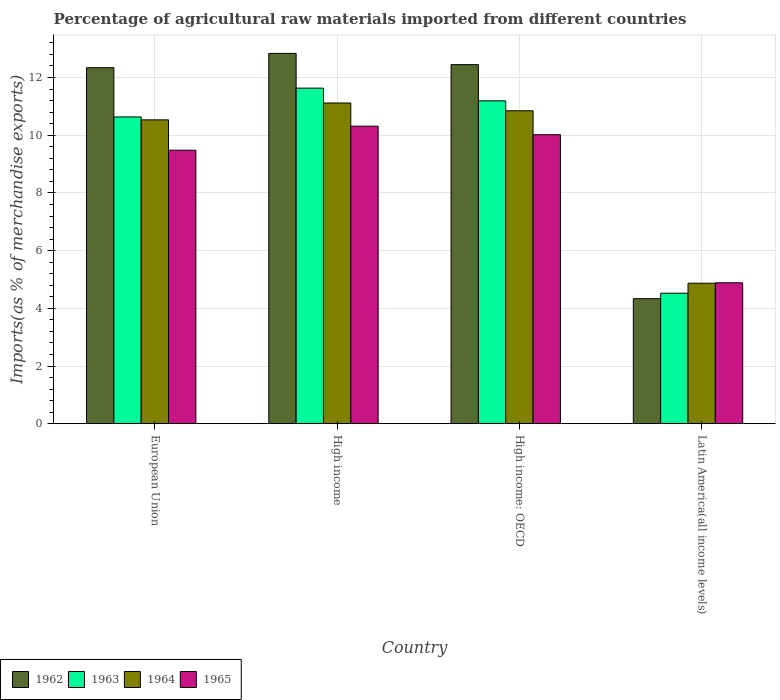How many different coloured bars are there?
Offer a very short reply. 4. Are the number of bars on each tick of the X-axis equal?
Provide a succinct answer. Yes. How many bars are there on the 4th tick from the right?
Provide a short and direct response. 4. What is the label of the 3rd group of bars from the left?
Your response must be concise. High income: OECD. In how many cases, is the number of bars for a given country not equal to the number of legend labels?
Offer a very short reply. 0. What is the percentage of imports to different countries in 1962 in High income?
Offer a very short reply. 12.84. Across all countries, what is the maximum percentage of imports to different countries in 1964?
Provide a succinct answer. 11.12. Across all countries, what is the minimum percentage of imports to different countries in 1965?
Give a very brief answer. 4.89. In which country was the percentage of imports to different countries in 1965 minimum?
Offer a very short reply. Latin America(all income levels). What is the total percentage of imports to different countries in 1964 in the graph?
Provide a succinct answer. 37.37. What is the difference between the percentage of imports to different countries in 1962 in High income: OECD and that in Latin America(all income levels)?
Offer a terse response. 8.11. What is the difference between the percentage of imports to different countries in 1964 in Latin America(all income levels) and the percentage of imports to different countries in 1962 in High income: OECD?
Your response must be concise. -7.58. What is the average percentage of imports to different countries in 1964 per country?
Keep it short and to the point. 9.34. What is the difference between the percentage of imports to different countries of/in 1963 and percentage of imports to different countries of/in 1965 in Latin America(all income levels)?
Give a very brief answer. -0.36. What is the ratio of the percentage of imports to different countries in 1964 in High income to that in Latin America(all income levels)?
Your answer should be very brief. 2.28. Is the percentage of imports to different countries in 1963 in European Union less than that in High income?
Your answer should be compact. Yes. What is the difference between the highest and the second highest percentage of imports to different countries in 1963?
Offer a terse response. 0.56. What is the difference between the highest and the lowest percentage of imports to different countries in 1962?
Keep it short and to the point. 8.5. In how many countries, is the percentage of imports to different countries in 1962 greater than the average percentage of imports to different countries in 1962 taken over all countries?
Give a very brief answer. 3. Is it the case that in every country, the sum of the percentage of imports to different countries in 1962 and percentage of imports to different countries in 1964 is greater than the sum of percentage of imports to different countries in 1963 and percentage of imports to different countries in 1965?
Provide a short and direct response. No. What does the 3rd bar from the left in Latin America(all income levels) represents?
Keep it short and to the point. 1964. What does the 2nd bar from the right in High income represents?
Keep it short and to the point. 1964. Are all the bars in the graph horizontal?
Your answer should be compact. No. How many countries are there in the graph?
Your response must be concise. 4. What is the difference between two consecutive major ticks on the Y-axis?
Give a very brief answer. 2. Are the values on the major ticks of Y-axis written in scientific E-notation?
Offer a very short reply. No. Does the graph contain grids?
Keep it short and to the point. Yes. How are the legend labels stacked?
Your answer should be very brief. Horizontal. What is the title of the graph?
Provide a succinct answer. Percentage of agricultural raw materials imported from different countries. What is the label or title of the Y-axis?
Give a very brief answer. Imports(as % of merchandise exports). What is the Imports(as % of merchandise exports) in 1962 in European Union?
Provide a succinct answer. 12.34. What is the Imports(as % of merchandise exports) of 1963 in European Union?
Keep it short and to the point. 10.63. What is the Imports(as % of merchandise exports) in 1964 in European Union?
Provide a short and direct response. 10.53. What is the Imports(as % of merchandise exports) in 1965 in European Union?
Your answer should be very brief. 9.48. What is the Imports(as % of merchandise exports) of 1962 in High income?
Provide a short and direct response. 12.84. What is the Imports(as % of merchandise exports) in 1963 in High income?
Provide a short and direct response. 11.63. What is the Imports(as % of merchandise exports) in 1964 in High income?
Provide a short and direct response. 11.12. What is the Imports(as % of merchandise exports) in 1965 in High income?
Offer a very short reply. 10.31. What is the Imports(as % of merchandise exports) in 1962 in High income: OECD?
Your response must be concise. 12.45. What is the Imports(as % of merchandise exports) in 1963 in High income: OECD?
Provide a succinct answer. 11.19. What is the Imports(as % of merchandise exports) in 1964 in High income: OECD?
Offer a very short reply. 10.85. What is the Imports(as % of merchandise exports) in 1965 in High income: OECD?
Offer a very short reply. 10.02. What is the Imports(as % of merchandise exports) in 1962 in Latin America(all income levels)?
Provide a succinct answer. 4.33. What is the Imports(as % of merchandise exports) in 1963 in Latin America(all income levels)?
Give a very brief answer. 4.52. What is the Imports(as % of merchandise exports) of 1964 in Latin America(all income levels)?
Make the answer very short. 4.87. What is the Imports(as % of merchandise exports) of 1965 in Latin America(all income levels)?
Your response must be concise. 4.89. Across all countries, what is the maximum Imports(as % of merchandise exports) in 1962?
Offer a very short reply. 12.84. Across all countries, what is the maximum Imports(as % of merchandise exports) in 1963?
Give a very brief answer. 11.63. Across all countries, what is the maximum Imports(as % of merchandise exports) of 1964?
Your answer should be very brief. 11.12. Across all countries, what is the maximum Imports(as % of merchandise exports) of 1965?
Your response must be concise. 10.31. Across all countries, what is the minimum Imports(as % of merchandise exports) of 1962?
Make the answer very short. 4.33. Across all countries, what is the minimum Imports(as % of merchandise exports) in 1963?
Your response must be concise. 4.52. Across all countries, what is the minimum Imports(as % of merchandise exports) in 1964?
Make the answer very short. 4.87. Across all countries, what is the minimum Imports(as % of merchandise exports) in 1965?
Make the answer very short. 4.89. What is the total Imports(as % of merchandise exports) in 1962 in the graph?
Offer a very short reply. 41.96. What is the total Imports(as % of merchandise exports) in 1963 in the graph?
Provide a short and direct response. 37.98. What is the total Imports(as % of merchandise exports) of 1964 in the graph?
Make the answer very short. 37.37. What is the total Imports(as % of merchandise exports) of 1965 in the graph?
Give a very brief answer. 34.7. What is the difference between the Imports(as % of merchandise exports) in 1962 in European Union and that in High income?
Your answer should be very brief. -0.5. What is the difference between the Imports(as % of merchandise exports) in 1963 in European Union and that in High income?
Provide a succinct answer. -1. What is the difference between the Imports(as % of merchandise exports) of 1964 in European Union and that in High income?
Offer a very short reply. -0.58. What is the difference between the Imports(as % of merchandise exports) of 1965 in European Union and that in High income?
Ensure brevity in your answer.  -0.83. What is the difference between the Imports(as % of merchandise exports) of 1962 in European Union and that in High income: OECD?
Give a very brief answer. -0.11. What is the difference between the Imports(as % of merchandise exports) of 1963 in European Union and that in High income: OECD?
Keep it short and to the point. -0.56. What is the difference between the Imports(as % of merchandise exports) in 1964 in European Union and that in High income: OECD?
Offer a terse response. -0.31. What is the difference between the Imports(as % of merchandise exports) in 1965 in European Union and that in High income: OECD?
Provide a succinct answer. -0.54. What is the difference between the Imports(as % of merchandise exports) of 1962 in European Union and that in Latin America(all income levels)?
Make the answer very short. 8.01. What is the difference between the Imports(as % of merchandise exports) of 1963 in European Union and that in Latin America(all income levels)?
Offer a terse response. 6.11. What is the difference between the Imports(as % of merchandise exports) of 1964 in European Union and that in Latin America(all income levels)?
Your response must be concise. 5.66. What is the difference between the Imports(as % of merchandise exports) of 1965 in European Union and that in Latin America(all income levels)?
Your response must be concise. 4.59. What is the difference between the Imports(as % of merchandise exports) in 1962 in High income and that in High income: OECD?
Ensure brevity in your answer.  0.39. What is the difference between the Imports(as % of merchandise exports) in 1963 in High income and that in High income: OECD?
Provide a short and direct response. 0.44. What is the difference between the Imports(as % of merchandise exports) of 1964 in High income and that in High income: OECD?
Offer a terse response. 0.27. What is the difference between the Imports(as % of merchandise exports) in 1965 in High income and that in High income: OECD?
Make the answer very short. 0.3. What is the difference between the Imports(as % of merchandise exports) of 1962 in High income and that in Latin America(all income levels)?
Your answer should be very brief. 8.5. What is the difference between the Imports(as % of merchandise exports) in 1963 in High income and that in Latin America(all income levels)?
Ensure brevity in your answer.  7.11. What is the difference between the Imports(as % of merchandise exports) in 1964 in High income and that in Latin America(all income levels)?
Make the answer very short. 6.25. What is the difference between the Imports(as % of merchandise exports) of 1965 in High income and that in Latin America(all income levels)?
Your answer should be compact. 5.43. What is the difference between the Imports(as % of merchandise exports) of 1962 in High income: OECD and that in Latin America(all income levels)?
Give a very brief answer. 8.11. What is the difference between the Imports(as % of merchandise exports) in 1963 in High income: OECD and that in Latin America(all income levels)?
Make the answer very short. 6.67. What is the difference between the Imports(as % of merchandise exports) in 1964 in High income: OECD and that in Latin America(all income levels)?
Your answer should be very brief. 5.98. What is the difference between the Imports(as % of merchandise exports) in 1965 in High income: OECD and that in Latin America(all income levels)?
Your answer should be very brief. 5.13. What is the difference between the Imports(as % of merchandise exports) in 1962 in European Union and the Imports(as % of merchandise exports) in 1963 in High income?
Your answer should be compact. 0.71. What is the difference between the Imports(as % of merchandise exports) in 1962 in European Union and the Imports(as % of merchandise exports) in 1964 in High income?
Your response must be concise. 1.22. What is the difference between the Imports(as % of merchandise exports) in 1962 in European Union and the Imports(as % of merchandise exports) in 1965 in High income?
Offer a terse response. 2.03. What is the difference between the Imports(as % of merchandise exports) in 1963 in European Union and the Imports(as % of merchandise exports) in 1964 in High income?
Your answer should be very brief. -0.48. What is the difference between the Imports(as % of merchandise exports) of 1963 in European Union and the Imports(as % of merchandise exports) of 1965 in High income?
Your answer should be very brief. 0.32. What is the difference between the Imports(as % of merchandise exports) of 1964 in European Union and the Imports(as % of merchandise exports) of 1965 in High income?
Offer a terse response. 0.22. What is the difference between the Imports(as % of merchandise exports) of 1962 in European Union and the Imports(as % of merchandise exports) of 1963 in High income: OECD?
Ensure brevity in your answer.  1.15. What is the difference between the Imports(as % of merchandise exports) in 1962 in European Union and the Imports(as % of merchandise exports) in 1964 in High income: OECD?
Keep it short and to the point. 1.49. What is the difference between the Imports(as % of merchandise exports) in 1962 in European Union and the Imports(as % of merchandise exports) in 1965 in High income: OECD?
Provide a short and direct response. 2.32. What is the difference between the Imports(as % of merchandise exports) of 1963 in European Union and the Imports(as % of merchandise exports) of 1964 in High income: OECD?
Your answer should be very brief. -0.21. What is the difference between the Imports(as % of merchandise exports) in 1963 in European Union and the Imports(as % of merchandise exports) in 1965 in High income: OECD?
Ensure brevity in your answer.  0.62. What is the difference between the Imports(as % of merchandise exports) in 1964 in European Union and the Imports(as % of merchandise exports) in 1965 in High income: OECD?
Your answer should be very brief. 0.51. What is the difference between the Imports(as % of merchandise exports) of 1962 in European Union and the Imports(as % of merchandise exports) of 1963 in Latin America(all income levels)?
Offer a very short reply. 7.82. What is the difference between the Imports(as % of merchandise exports) in 1962 in European Union and the Imports(as % of merchandise exports) in 1964 in Latin America(all income levels)?
Your response must be concise. 7.47. What is the difference between the Imports(as % of merchandise exports) in 1962 in European Union and the Imports(as % of merchandise exports) in 1965 in Latin America(all income levels)?
Give a very brief answer. 7.46. What is the difference between the Imports(as % of merchandise exports) in 1963 in European Union and the Imports(as % of merchandise exports) in 1964 in Latin America(all income levels)?
Your response must be concise. 5.76. What is the difference between the Imports(as % of merchandise exports) of 1963 in European Union and the Imports(as % of merchandise exports) of 1965 in Latin America(all income levels)?
Provide a short and direct response. 5.75. What is the difference between the Imports(as % of merchandise exports) of 1964 in European Union and the Imports(as % of merchandise exports) of 1965 in Latin America(all income levels)?
Make the answer very short. 5.65. What is the difference between the Imports(as % of merchandise exports) of 1962 in High income and the Imports(as % of merchandise exports) of 1963 in High income: OECD?
Provide a short and direct response. 1.64. What is the difference between the Imports(as % of merchandise exports) of 1962 in High income and the Imports(as % of merchandise exports) of 1964 in High income: OECD?
Offer a terse response. 1.99. What is the difference between the Imports(as % of merchandise exports) in 1962 in High income and the Imports(as % of merchandise exports) in 1965 in High income: OECD?
Your answer should be compact. 2.82. What is the difference between the Imports(as % of merchandise exports) in 1963 in High income and the Imports(as % of merchandise exports) in 1964 in High income: OECD?
Your answer should be compact. 0.78. What is the difference between the Imports(as % of merchandise exports) of 1963 in High income and the Imports(as % of merchandise exports) of 1965 in High income: OECD?
Provide a short and direct response. 1.61. What is the difference between the Imports(as % of merchandise exports) in 1964 in High income and the Imports(as % of merchandise exports) in 1965 in High income: OECD?
Keep it short and to the point. 1.1. What is the difference between the Imports(as % of merchandise exports) in 1962 in High income and the Imports(as % of merchandise exports) in 1963 in Latin America(all income levels)?
Provide a short and direct response. 8.31. What is the difference between the Imports(as % of merchandise exports) in 1962 in High income and the Imports(as % of merchandise exports) in 1964 in Latin America(all income levels)?
Your response must be concise. 7.97. What is the difference between the Imports(as % of merchandise exports) in 1962 in High income and the Imports(as % of merchandise exports) in 1965 in Latin America(all income levels)?
Keep it short and to the point. 7.95. What is the difference between the Imports(as % of merchandise exports) in 1963 in High income and the Imports(as % of merchandise exports) in 1964 in Latin America(all income levels)?
Make the answer very short. 6.76. What is the difference between the Imports(as % of merchandise exports) of 1963 in High income and the Imports(as % of merchandise exports) of 1965 in Latin America(all income levels)?
Keep it short and to the point. 6.75. What is the difference between the Imports(as % of merchandise exports) in 1964 in High income and the Imports(as % of merchandise exports) in 1965 in Latin America(all income levels)?
Offer a terse response. 6.23. What is the difference between the Imports(as % of merchandise exports) in 1962 in High income: OECD and the Imports(as % of merchandise exports) in 1963 in Latin America(all income levels)?
Ensure brevity in your answer.  7.92. What is the difference between the Imports(as % of merchandise exports) in 1962 in High income: OECD and the Imports(as % of merchandise exports) in 1964 in Latin America(all income levels)?
Provide a succinct answer. 7.58. What is the difference between the Imports(as % of merchandise exports) in 1962 in High income: OECD and the Imports(as % of merchandise exports) in 1965 in Latin America(all income levels)?
Provide a succinct answer. 7.56. What is the difference between the Imports(as % of merchandise exports) in 1963 in High income: OECD and the Imports(as % of merchandise exports) in 1964 in Latin America(all income levels)?
Your answer should be very brief. 6.32. What is the difference between the Imports(as % of merchandise exports) of 1963 in High income: OECD and the Imports(as % of merchandise exports) of 1965 in Latin America(all income levels)?
Provide a short and direct response. 6.31. What is the difference between the Imports(as % of merchandise exports) of 1964 in High income: OECD and the Imports(as % of merchandise exports) of 1965 in Latin America(all income levels)?
Ensure brevity in your answer.  5.96. What is the average Imports(as % of merchandise exports) in 1962 per country?
Ensure brevity in your answer.  10.49. What is the average Imports(as % of merchandise exports) of 1963 per country?
Provide a succinct answer. 9.5. What is the average Imports(as % of merchandise exports) in 1964 per country?
Ensure brevity in your answer.  9.34. What is the average Imports(as % of merchandise exports) in 1965 per country?
Provide a succinct answer. 8.67. What is the difference between the Imports(as % of merchandise exports) in 1962 and Imports(as % of merchandise exports) in 1963 in European Union?
Provide a short and direct response. 1.71. What is the difference between the Imports(as % of merchandise exports) in 1962 and Imports(as % of merchandise exports) in 1964 in European Union?
Provide a short and direct response. 1.81. What is the difference between the Imports(as % of merchandise exports) in 1962 and Imports(as % of merchandise exports) in 1965 in European Union?
Give a very brief answer. 2.86. What is the difference between the Imports(as % of merchandise exports) of 1963 and Imports(as % of merchandise exports) of 1964 in European Union?
Provide a succinct answer. 0.1. What is the difference between the Imports(as % of merchandise exports) in 1963 and Imports(as % of merchandise exports) in 1965 in European Union?
Your answer should be very brief. 1.15. What is the difference between the Imports(as % of merchandise exports) in 1964 and Imports(as % of merchandise exports) in 1965 in European Union?
Ensure brevity in your answer.  1.05. What is the difference between the Imports(as % of merchandise exports) of 1962 and Imports(as % of merchandise exports) of 1963 in High income?
Offer a terse response. 1.2. What is the difference between the Imports(as % of merchandise exports) in 1962 and Imports(as % of merchandise exports) in 1964 in High income?
Provide a short and direct response. 1.72. What is the difference between the Imports(as % of merchandise exports) in 1962 and Imports(as % of merchandise exports) in 1965 in High income?
Your response must be concise. 2.52. What is the difference between the Imports(as % of merchandise exports) of 1963 and Imports(as % of merchandise exports) of 1964 in High income?
Provide a succinct answer. 0.52. What is the difference between the Imports(as % of merchandise exports) in 1963 and Imports(as % of merchandise exports) in 1965 in High income?
Offer a very short reply. 1.32. What is the difference between the Imports(as % of merchandise exports) of 1964 and Imports(as % of merchandise exports) of 1965 in High income?
Make the answer very short. 0.8. What is the difference between the Imports(as % of merchandise exports) of 1962 and Imports(as % of merchandise exports) of 1963 in High income: OECD?
Offer a very short reply. 1.25. What is the difference between the Imports(as % of merchandise exports) of 1962 and Imports(as % of merchandise exports) of 1964 in High income: OECD?
Make the answer very short. 1.6. What is the difference between the Imports(as % of merchandise exports) in 1962 and Imports(as % of merchandise exports) in 1965 in High income: OECD?
Your answer should be very brief. 2.43. What is the difference between the Imports(as % of merchandise exports) of 1963 and Imports(as % of merchandise exports) of 1964 in High income: OECD?
Your answer should be very brief. 0.34. What is the difference between the Imports(as % of merchandise exports) in 1963 and Imports(as % of merchandise exports) in 1965 in High income: OECD?
Your answer should be very brief. 1.17. What is the difference between the Imports(as % of merchandise exports) of 1964 and Imports(as % of merchandise exports) of 1965 in High income: OECD?
Provide a succinct answer. 0.83. What is the difference between the Imports(as % of merchandise exports) in 1962 and Imports(as % of merchandise exports) in 1963 in Latin America(all income levels)?
Offer a very short reply. -0.19. What is the difference between the Imports(as % of merchandise exports) of 1962 and Imports(as % of merchandise exports) of 1964 in Latin America(all income levels)?
Give a very brief answer. -0.54. What is the difference between the Imports(as % of merchandise exports) in 1962 and Imports(as % of merchandise exports) in 1965 in Latin America(all income levels)?
Ensure brevity in your answer.  -0.55. What is the difference between the Imports(as % of merchandise exports) in 1963 and Imports(as % of merchandise exports) in 1964 in Latin America(all income levels)?
Provide a short and direct response. -0.35. What is the difference between the Imports(as % of merchandise exports) of 1963 and Imports(as % of merchandise exports) of 1965 in Latin America(all income levels)?
Your response must be concise. -0.36. What is the difference between the Imports(as % of merchandise exports) of 1964 and Imports(as % of merchandise exports) of 1965 in Latin America(all income levels)?
Your answer should be compact. -0.02. What is the ratio of the Imports(as % of merchandise exports) of 1962 in European Union to that in High income?
Ensure brevity in your answer.  0.96. What is the ratio of the Imports(as % of merchandise exports) in 1963 in European Union to that in High income?
Provide a short and direct response. 0.91. What is the ratio of the Imports(as % of merchandise exports) in 1964 in European Union to that in High income?
Provide a short and direct response. 0.95. What is the ratio of the Imports(as % of merchandise exports) in 1965 in European Union to that in High income?
Ensure brevity in your answer.  0.92. What is the ratio of the Imports(as % of merchandise exports) in 1963 in European Union to that in High income: OECD?
Provide a short and direct response. 0.95. What is the ratio of the Imports(as % of merchandise exports) in 1964 in European Union to that in High income: OECD?
Your answer should be compact. 0.97. What is the ratio of the Imports(as % of merchandise exports) in 1965 in European Union to that in High income: OECD?
Offer a terse response. 0.95. What is the ratio of the Imports(as % of merchandise exports) of 1962 in European Union to that in Latin America(all income levels)?
Offer a terse response. 2.85. What is the ratio of the Imports(as % of merchandise exports) of 1963 in European Union to that in Latin America(all income levels)?
Ensure brevity in your answer.  2.35. What is the ratio of the Imports(as % of merchandise exports) of 1964 in European Union to that in Latin America(all income levels)?
Provide a short and direct response. 2.16. What is the ratio of the Imports(as % of merchandise exports) in 1965 in European Union to that in Latin America(all income levels)?
Give a very brief answer. 1.94. What is the ratio of the Imports(as % of merchandise exports) in 1962 in High income to that in High income: OECD?
Your response must be concise. 1.03. What is the ratio of the Imports(as % of merchandise exports) in 1963 in High income to that in High income: OECD?
Your answer should be compact. 1.04. What is the ratio of the Imports(as % of merchandise exports) of 1964 in High income to that in High income: OECD?
Give a very brief answer. 1.02. What is the ratio of the Imports(as % of merchandise exports) in 1965 in High income to that in High income: OECD?
Your answer should be very brief. 1.03. What is the ratio of the Imports(as % of merchandise exports) of 1962 in High income to that in Latin America(all income levels)?
Keep it short and to the point. 2.96. What is the ratio of the Imports(as % of merchandise exports) in 1963 in High income to that in Latin America(all income levels)?
Your answer should be very brief. 2.57. What is the ratio of the Imports(as % of merchandise exports) of 1964 in High income to that in Latin America(all income levels)?
Give a very brief answer. 2.28. What is the ratio of the Imports(as % of merchandise exports) in 1965 in High income to that in Latin America(all income levels)?
Make the answer very short. 2.11. What is the ratio of the Imports(as % of merchandise exports) of 1962 in High income: OECD to that in Latin America(all income levels)?
Keep it short and to the point. 2.87. What is the ratio of the Imports(as % of merchandise exports) of 1963 in High income: OECD to that in Latin America(all income levels)?
Your answer should be compact. 2.47. What is the ratio of the Imports(as % of merchandise exports) of 1964 in High income: OECD to that in Latin America(all income levels)?
Your response must be concise. 2.23. What is the ratio of the Imports(as % of merchandise exports) in 1965 in High income: OECD to that in Latin America(all income levels)?
Your answer should be compact. 2.05. What is the difference between the highest and the second highest Imports(as % of merchandise exports) of 1962?
Your response must be concise. 0.39. What is the difference between the highest and the second highest Imports(as % of merchandise exports) of 1963?
Offer a very short reply. 0.44. What is the difference between the highest and the second highest Imports(as % of merchandise exports) in 1964?
Give a very brief answer. 0.27. What is the difference between the highest and the second highest Imports(as % of merchandise exports) of 1965?
Provide a succinct answer. 0.3. What is the difference between the highest and the lowest Imports(as % of merchandise exports) in 1962?
Your answer should be compact. 8.5. What is the difference between the highest and the lowest Imports(as % of merchandise exports) in 1963?
Ensure brevity in your answer.  7.11. What is the difference between the highest and the lowest Imports(as % of merchandise exports) in 1964?
Provide a succinct answer. 6.25. What is the difference between the highest and the lowest Imports(as % of merchandise exports) of 1965?
Your answer should be very brief. 5.43. 